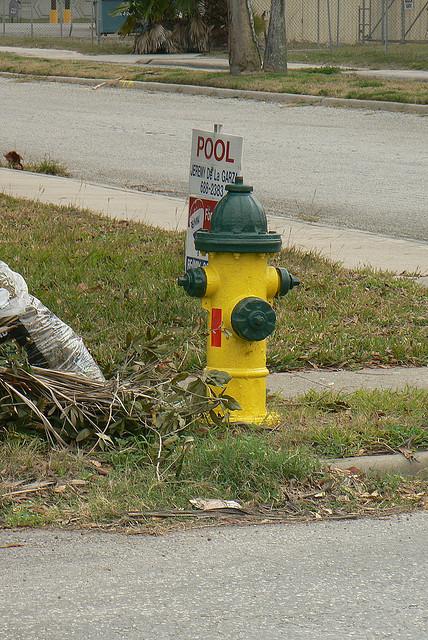What color is the word "pool" in this scene?
Quick response, please. Red. What color is the hydrant?
Keep it brief. Yellow and green. Where is the fire hydrant?
Answer briefly. Corner. What color is the fire hydrant?
Concise answer only. Yellow and green. 